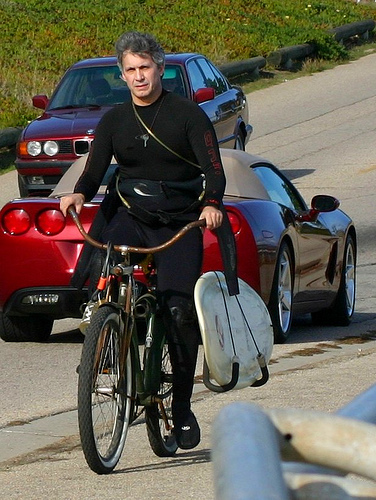<image>What is the make of the motorcycle? I don't know the make of the motorcycle. It could be a Schwinn, a Trek, or a Honda. But there's also a possibility that there is no motorcycle. What is the make of the motorcycle? I don't know the make of the motorcycle. It can be 'schwinn', 'treck', 'honda' or 'bicycle'. 